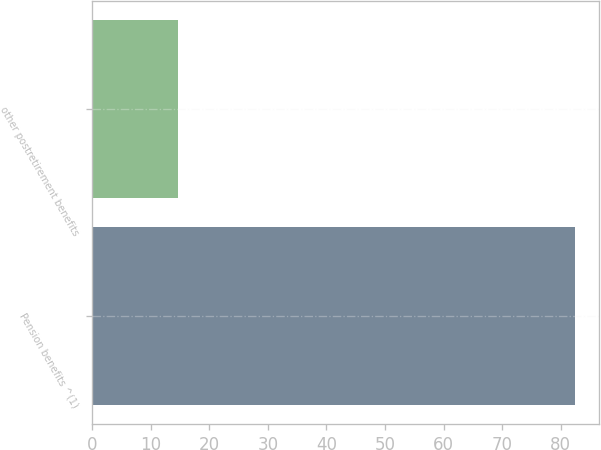Convert chart to OTSL. <chart><loc_0><loc_0><loc_500><loc_500><bar_chart><fcel>Pension benefits ^(1)<fcel>other postretirement benefits<nl><fcel>82.4<fcel>14.7<nl></chart> 